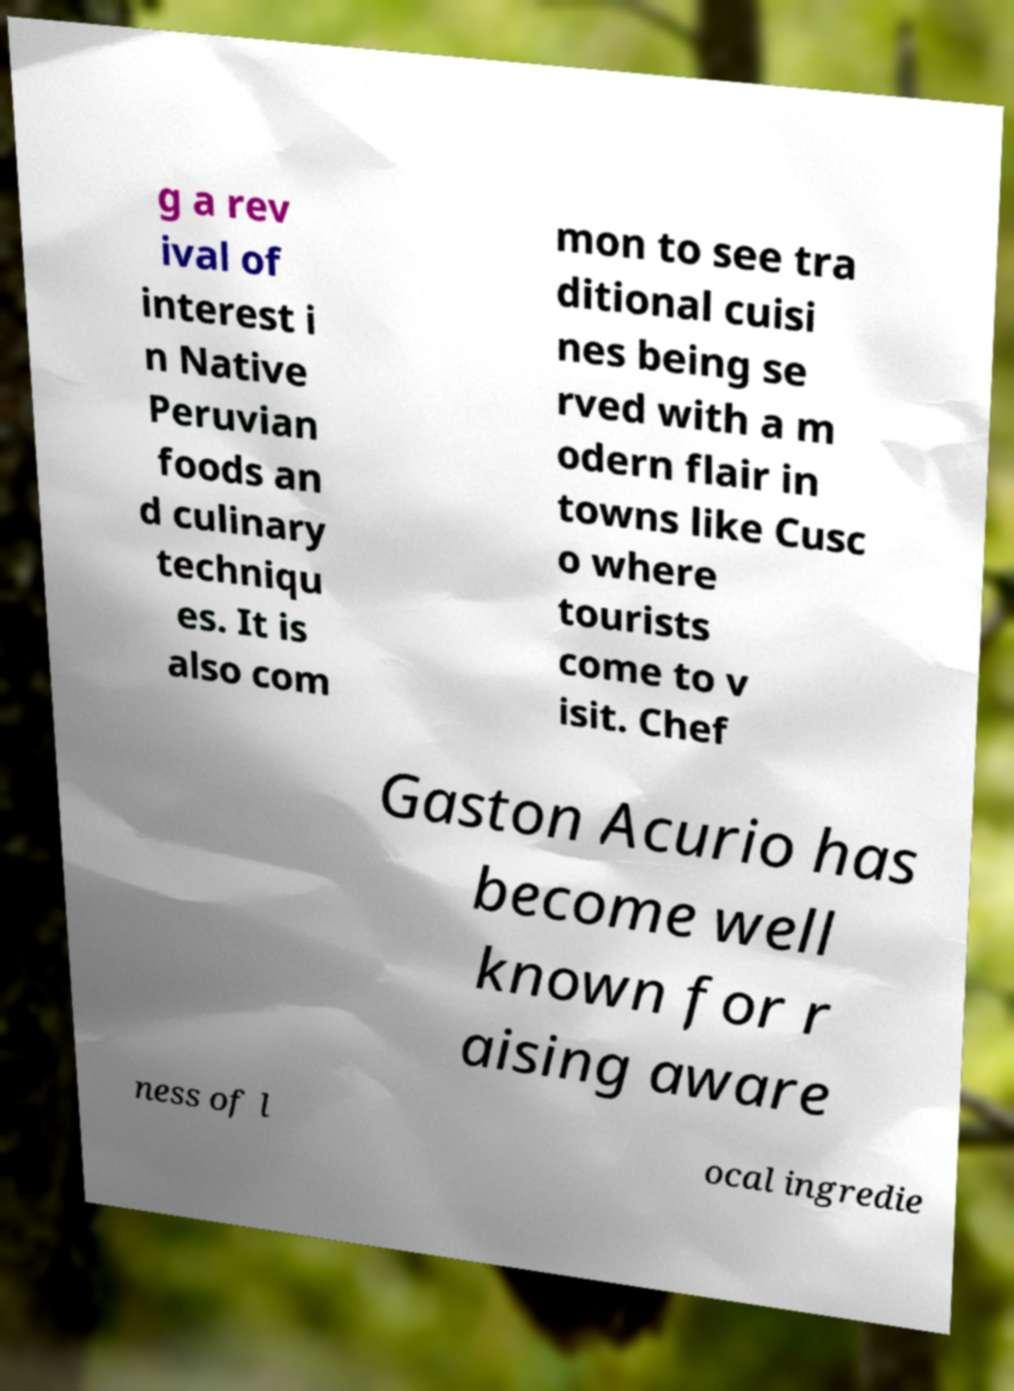There's text embedded in this image that I need extracted. Can you transcribe it verbatim? g a rev ival of interest i n Native Peruvian foods an d culinary techniqu es. It is also com mon to see tra ditional cuisi nes being se rved with a m odern flair in towns like Cusc o where tourists come to v isit. Chef Gaston Acurio has become well known for r aising aware ness of l ocal ingredie 